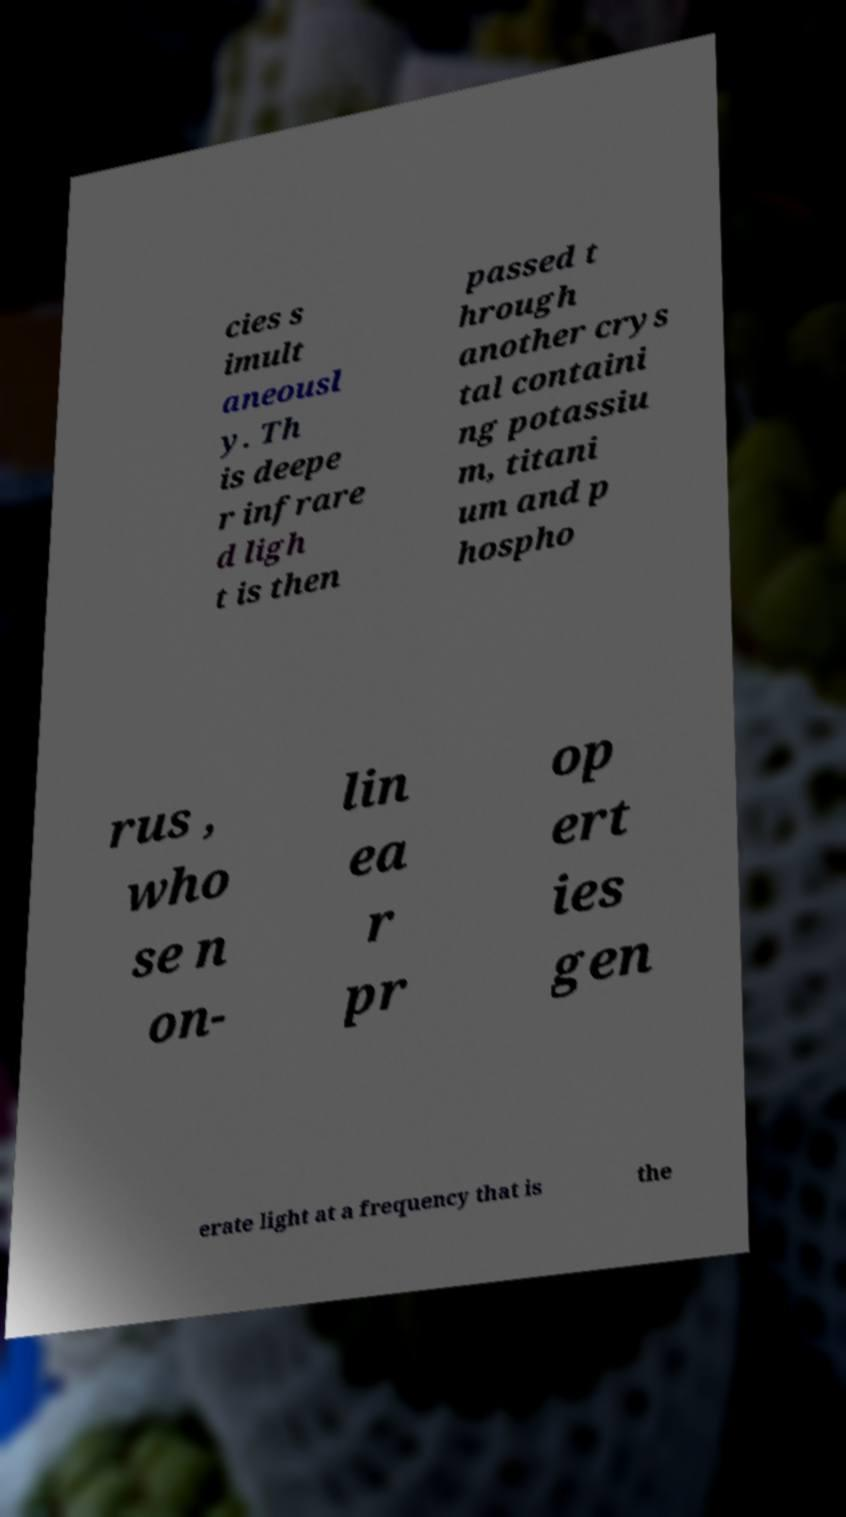There's text embedded in this image that I need extracted. Can you transcribe it verbatim? cies s imult aneousl y. Th is deepe r infrare d ligh t is then passed t hrough another crys tal containi ng potassiu m, titani um and p hospho rus , who se n on- lin ea r pr op ert ies gen erate light at a frequency that is the 